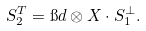Convert formula to latex. <formula><loc_0><loc_0><loc_500><loc_500>S _ { 2 } ^ { T } = \i d \otimes X \cdot S _ { 1 } ^ { \perp } .</formula> 